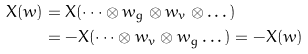Convert formula to latex. <formula><loc_0><loc_0><loc_500><loc_500>X ( w ) & = X ( \dots \otimes w _ { g } \otimes w _ { v } \otimes \dots ) \\ & = - X ( \dots \otimes w _ { v } \otimes w _ { g } \dots ) = - X ( w )</formula> 